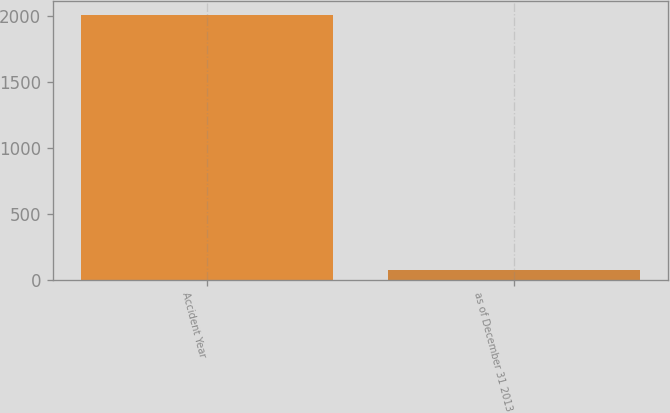<chart> <loc_0><loc_0><loc_500><loc_500><bar_chart><fcel>Accident Year<fcel>as of December 31 2013<nl><fcel>2012<fcel>75.7<nl></chart> 